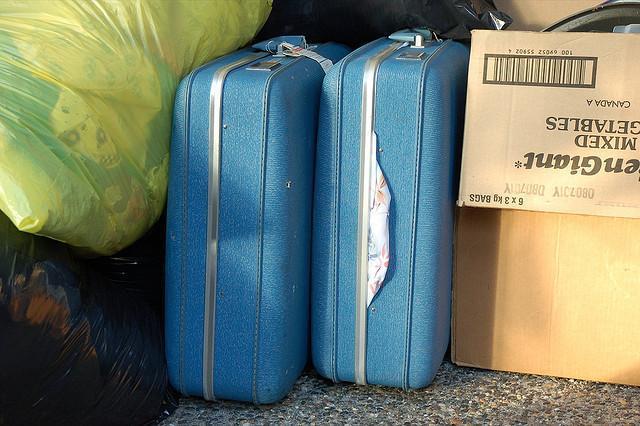How many suitcases can you see?
Give a very brief answer. 2. 